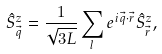<formula> <loc_0><loc_0><loc_500><loc_500>\hat { S } ^ { z } _ { \vec { q } } = \frac { 1 } { \sqrt { 3 L } } \sum _ { l } e ^ { i { \vec { q } } \cdot { \vec { r } } } \hat { S } ^ { z } _ { \vec { r } } ,</formula> 